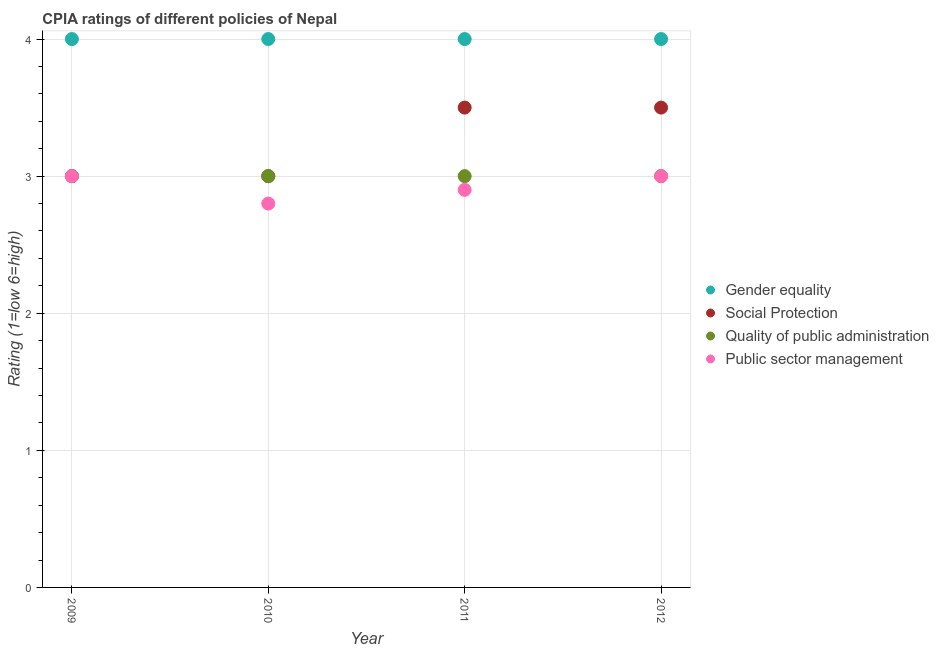What is the cpia rating of gender equality in 2009?
Make the answer very short. 4. Across all years, what is the maximum cpia rating of public sector management?
Your answer should be compact. 3. Across all years, what is the minimum cpia rating of social protection?
Provide a succinct answer. 3. In which year was the cpia rating of gender equality minimum?
Your answer should be very brief. 2009. What is the total cpia rating of gender equality in the graph?
Offer a very short reply. 16. What is the difference between the cpia rating of quality of public administration in 2009 and that in 2011?
Keep it short and to the point. 0. What is the average cpia rating of gender equality per year?
Ensure brevity in your answer.  4. In how many years, is the cpia rating of public sector management greater than 2?
Your answer should be compact. 4. What is the ratio of the cpia rating of social protection in 2009 to that in 2012?
Your answer should be compact. 0.86. Is the cpia rating of gender equality in 2010 less than that in 2012?
Make the answer very short. No. Is the difference between the cpia rating of gender equality in 2009 and 2012 greater than the difference between the cpia rating of social protection in 2009 and 2012?
Make the answer very short. Yes. What is the difference between the highest and the second highest cpia rating of public sector management?
Offer a terse response. 0. Is the sum of the cpia rating of public sector management in 2009 and 2010 greater than the maximum cpia rating of quality of public administration across all years?
Offer a very short reply. Yes. Is it the case that in every year, the sum of the cpia rating of gender equality and cpia rating of social protection is greater than the cpia rating of quality of public administration?
Give a very brief answer. Yes. Does the cpia rating of gender equality monotonically increase over the years?
Your answer should be very brief. No. Is the cpia rating of quality of public administration strictly less than the cpia rating of social protection over the years?
Keep it short and to the point. No. How many years are there in the graph?
Keep it short and to the point. 4. Are the values on the major ticks of Y-axis written in scientific E-notation?
Your response must be concise. No. Does the graph contain any zero values?
Your answer should be compact. No. Where does the legend appear in the graph?
Offer a terse response. Center right. What is the title of the graph?
Provide a short and direct response. CPIA ratings of different policies of Nepal. What is the Rating (1=low 6=high) in Gender equality in 2009?
Provide a succinct answer. 4. What is the Rating (1=low 6=high) in Social Protection in 2009?
Provide a short and direct response. 3. What is the Rating (1=low 6=high) of Quality of public administration in 2009?
Provide a succinct answer. 3. What is the Rating (1=low 6=high) of Public sector management in 2009?
Give a very brief answer. 3. What is the Rating (1=low 6=high) of Social Protection in 2010?
Your answer should be very brief. 3. What is the Rating (1=low 6=high) in Quality of public administration in 2010?
Make the answer very short. 3. What is the Rating (1=low 6=high) in Gender equality in 2011?
Keep it short and to the point. 4. What is the Rating (1=low 6=high) in Social Protection in 2012?
Provide a short and direct response. 3.5. What is the Rating (1=low 6=high) of Quality of public administration in 2012?
Offer a terse response. 3. What is the Rating (1=low 6=high) of Public sector management in 2012?
Make the answer very short. 3. Across all years, what is the maximum Rating (1=low 6=high) of Gender equality?
Give a very brief answer. 4. Across all years, what is the maximum Rating (1=low 6=high) in Social Protection?
Make the answer very short. 3.5. Across all years, what is the maximum Rating (1=low 6=high) of Public sector management?
Ensure brevity in your answer.  3. Across all years, what is the minimum Rating (1=low 6=high) in Gender equality?
Offer a terse response. 4. Across all years, what is the minimum Rating (1=low 6=high) of Social Protection?
Keep it short and to the point. 3. Across all years, what is the minimum Rating (1=low 6=high) of Quality of public administration?
Provide a succinct answer. 3. Across all years, what is the minimum Rating (1=low 6=high) in Public sector management?
Your answer should be compact. 2.8. What is the total Rating (1=low 6=high) of Social Protection in the graph?
Offer a very short reply. 13. What is the total Rating (1=low 6=high) in Quality of public administration in the graph?
Make the answer very short. 12. What is the total Rating (1=low 6=high) in Public sector management in the graph?
Keep it short and to the point. 11.7. What is the difference between the Rating (1=low 6=high) of Gender equality in 2009 and that in 2010?
Provide a short and direct response. 0. What is the difference between the Rating (1=low 6=high) of Social Protection in 2009 and that in 2010?
Make the answer very short. 0. What is the difference between the Rating (1=low 6=high) of Quality of public administration in 2009 and that in 2010?
Keep it short and to the point. 0. What is the difference between the Rating (1=low 6=high) in Gender equality in 2009 and that in 2011?
Offer a terse response. 0. What is the difference between the Rating (1=low 6=high) in Social Protection in 2009 and that in 2011?
Provide a short and direct response. -0.5. What is the difference between the Rating (1=low 6=high) of Quality of public administration in 2009 and that in 2011?
Provide a short and direct response. 0. What is the difference between the Rating (1=low 6=high) in Public sector management in 2009 and that in 2011?
Keep it short and to the point. 0.1. What is the difference between the Rating (1=low 6=high) in Social Protection in 2009 and that in 2012?
Keep it short and to the point. -0.5. What is the difference between the Rating (1=low 6=high) in Quality of public administration in 2009 and that in 2012?
Offer a terse response. 0. What is the difference between the Rating (1=low 6=high) in Public sector management in 2009 and that in 2012?
Your answer should be compact. 0. What is the difference between the Rating (1=low 6=high) in Quality of public administration in 2010 and that in 2011?
Make the answer very short. 0. What is the difference between the Rating (1=low 6=high) in Gender equality in 2010 and that in 2012?
Offer a terse response. 0. What is the difference between the Rating (1=low 6=high) of Social Protection in 2010 and that in 2012?
Ensure brevity in your answer.  -0.5. What is the difference between the Rating (1=low 6=high) in Quality of public administration in 2010 and that in 2012?
Ensure brevity in your answer.  0. What is the difference between the Rating (1=low 6=high) of Public sector management in 2010 and that in 2012?
Provide a succinct answer. -0.2. What is the difference between the Rating (1=low 6=high) in Gender equality in 2011 and that in 2012?
Offer a terse response. 0. What is the difference between the Rating (1=low 6=high) in Quality of public administration in 2011 and that in 2012?
Provide a short and direct response. 0. What is the difference between the Rating (1=low 6=high) of Public sector management in 2011 and that in 2012?
Your response must be concise. -0.1. What is the difference between the Rating (1=low 6=high) of Gender equality in 2009 and the Rating (1=low 6=high) of Quality of public administration in 2010?
Give a very brief answer. 1. What is the difference between the Rating (1=low 6=high) in Social Protection in 2009 and the Rating (1=low 6=high) in Quality of public administration in 2010?
Provide a succinct answer. 0. What is the difference between the Rating (1=low 6=high) in Social Protection in 2009 and the Rating (1=low 6=high) in Public sector management in 2010?
Your answer should be very brief. 0.2. What is the difference between the Rating (1=low 6=high) of Gender equality in 2009 and the Rating (1=low 6=high) of Social Protection in 2011?
Your answer should be very brief. 0.5. What is the difference between the Rating (1=low 6=high) in Social Protection in 2009 and the Rating (1=low 6=high) in Quality of public administration in 2011?
Your response must be concise. 0. What is the difference between the Rating (1=low 6=high) in Social Protection in 2009 and the Rating (1=low 6=high) in Public sector management in 2011?
Your response must be concise. 0.1. What is the difference between the Rating (1=low 6=high) in Gender equality in 2009 and the Rating (1=low 6=high) in Social Protection in 2012?
Make the answer very short. 0.5. What is the difference between the Rating (1=low 6=high) of Gender equality in 2009 and the Rating (1=low 6=high) of Quality of public administration in 2012?
Provide a succinct answer. 1. What is the difference between the Rating (1=low 6=high) of Social Protection in 2009 and the Rating (1=low 6=high) of Quality of public administration in 2012?
Offer a very short reply. 0. What is the difference between the Rating (1=low 6=high) of Gender equality in 2010 and the Rating (1=low 6=high) of Quality of public administration in 2011?
Your response must be concise. 1. What is the difference between the Rating (1=low 6=high) of Gender equality in 2010 and the Rating (1=low 6=high) of Public sector management in 2011?
Your answer should be compact. 1.1. What is the difference between the Rating (1=low 6=high) in Gender equality in 2010 and the Rating (1=low 6=high) in Social Protection in 2012?
Offer a very short reply. 0.5. What is the difference between the Rating (1=low 6=high) in Social Protection in 2010 and the Rating (1=low 6=high) in Public sector management in 2012?
Your answer should be very brief. 0. What is the difference between the Rating (1=low 6=high) in Quality of public administration in 2010 and the Rating (1=low 6=high) in Public sector management in 2012?
Offer a very short reply. 0. What is the difference between the Rating (1=low 6=high) of Social Protection in 2011 and the Rating (1=low 6=high) of Quality of public administration in 2012?
Ensure brevity in your answer.  0.5. What is the difference between the Rating (1=low 6=high) in Social Protection in 2011 and the Rating (1=low 6=high) in Public sector management in 2012?
Make the answer very short. 0.5. What is the difference between the Rating (1=low 6=high) of Quality of public administration in 2011 and the Rating (1=low 6=high) of Public sector management in 2012?
Give a very brief answer. 0. What is the average Rating (1=low 6=high) of Gender equality per year?
Offer a terse response. 4. What is the average Rating (1=low 6=high) of Social Protection per year?
Your answer should be compact. 3.25. What is the average Rating (1=low 6=high) in Public sector management per year?
Offer a very short reply. 2.92. In the year 2009, what is the difference between the Rating (1=low 6=high) in Gender equality and Rating (1=low 6=high) in Public sector management?
Provide a succinct answer. 1. In the year 2010, what is the difference between the Rating (1=low 6=high) of Gender equality and Rating (1=low 6=high) of Social Protection?
Offer a terse response. 1. In the year 2010, what is the difference between the Rating (1=low 6=high) in Gender equality and Rating (1=low 6=high) in Quality of public administration?
Offer a terse response. 1. In the year 2010, what is the difference between the Rating (1=low 6=high) of Gender equality and Rating (1=low 6=high) of Public sector management?
Give a very brief answer. 1.2. In the year 2010, what is the difference between the Rating (1=low 6=high) of Social Protection and Rating (1=low 6=high) of Quality of public administration?
Offer a terse response. 0. In the year 2011, what is the difference between the Rating (1=low 6=high) in Gender equality and Rating (1=low 6=high) in Social Protection?
Keep it short and to the point. 0.5. In the year 2011, what is the difference between the Rating (1=low 6=high) of Gender equality and Rating (1=low 6=high) of Quality of public administration?
Your answer should be very brief. 1. In the year 2011, what is the difference between the Rating (1=low 6=high) of Social Protection and Rating (1=low 6=high) of Quality of public administration?
Ensure brevity in your answer.  0.5. In the year 2011, what is the difference between the Rating (1=low 6=high) of Quality of public administration and Rating (1=low 6=high) of Public sector management?
Offer a very short reply. 0.1. In the year 2012, what is the difference between the Rating (1=low 6=high) of Gender equality and Rating (1=low 6=high) of Social Protection?
Provide a succinct answer. 0.5. In the year 2012, what is the difference between the Rating (1=low 6=high) in Gender equality and Rating (1=low 6=high) in Quality of public administration?
Provide a short and direct response. 1. In the year 2012, what is the difference between the Rating (1=low 6=high) of Gender equality and Rating (1=low 6=high) of Public sector management?
Your answer should be very brief. 1. In the year 2012, what is the difference between the Rating (1=low 6=high) in Social Protection and Rating (1=low 6=high) in Quality of public administration?
Provide a succinct answer. 0.5. In the year 2012, what is the difference between the Rating (1=low 6=high) of Social Protection and Rating (1=low 6=high) of Public sector management?
Your response must be concise. 0.5. What is the ratio of the Rating (1=low 6=high) in Social Protection in 2009 to that in 2010?
Offer a very short reply. 1. What is the ratio of the Rating (1=low 6=high) of Quality of public administration in 2009 to that in 2010?
Provide a short and direct response. 1. What is the ratio of the Rating (1=low 6=high) of Public sector management in 2009 to that in 2010?
Your answer should be compact. 1.07. What is the ratio of the Rating (1=low 6=high) of Social Protection in 2009 to that in 2011?
Give a very brief answer. 0.86. What is the ratio of the Rating (1=low 6=high) in Quality of public administration in 2009 to that in 2011?
Offer a terse response. 1. What is the ratio of the Rating (1=low 6=high) of Public sector management in 2009 to that in 2011?
Make the answer very short. 1.03. What is the ratio of the Rating (1=low 6=high) in Gender equality in 2010 to that in 2011?
Keep it short and to the point. 1. What is the ratio of the Rating (1=low 6=high) in Social Protection in 2010 to that in 2011?
Your response must be concise. 0.86. What is the ratio of the Rating (1=low 6=high) in Quality of public administration in 2010 to that in 2011?
Keep it short and to the point. 1. What is the ratio of the Rating (1=low 6=high) in Public sector management in 2010 to that in 2011?
Offer a terse response. 0.97. What is the ratio of the Rating (1=low 6=high) in Gender equality in 2010 to that in 2012?
Give a very brief answer. 1. What is the ratio of the Rating (1=low 6=high) in Social Protection in 2010 to that in 2012?
Give a very brief answer. 0.86. What is the ratio of the Rating (1=low 6=high) of Public sector management in 2010 to that in 2012?
Provide a short and direct response. 0.93. What is the ratio of the Rating (1=low 6=high) in Gender equality in 2011 to that in 2012?
Make the answer very short. 1. What is the ratio of the Rating (1=low 6=high) of Social Protection in 2011 to that in 2012?
Make the answer very short. 1. What is the ratio of the Rating (1=low 6=high) of Public sector management in 2011 to that in 2012?
Make the answer very short. 0.97. What is the difference between the highest and the second highest Rating (1=low 6=high) in Gender equality?
Provide a succinct answer. 0. What is the difference between the highest and the second highest Rating (1=low 6=high) in Quality of public administration?
Provide a short and direct response. 0. What is the difference between the highest and the lowest Rating (1=low 6=high) of Social Protection?
Provide a short and direct response. 0.5. What is the difference between the highest and the lowest Rating (1=low 6=high) of Quality of public administration?
Offer a very short reply. 0. What is the difference between the highest and the lowest Rating (1=low 6=high) of Public sector management?
Your answer should be very brief. 0.2. 